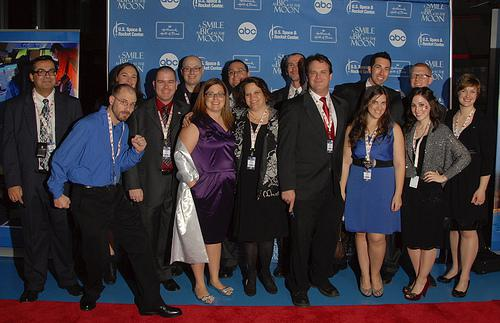Question: what network is being advertised?
Choices:
A. Nbc.
B. ABC.
C. Pbs.
D. Mtv.
Answer with the letter. Answer: B Question: what is hanging on their necks?
Choices:
A. Necklace.
B. Lanyards.
C. Glasses.
D. Towels.
Answer with the letter. Answer: B Question: why are they standing?
Choices:
A. To pose for a picture.
B. Exercise.
C. Stretch.
D. Walk.
Answer with the letter. Answer: A Question: what is on the arm of the woman in the purple blouse?
Choices:
A. A satin shawl.
B. Purse.
C. Towel.
D. Sweater.
Answer with the letter. Answer: A Question: who has dresses on?
Choices:
A. The women in front.
B. The bridesmaids.
C. The flowergirls.
D. The women in back.
Answer with the letter. Answer: A Question: who looks happy?
Choices:
A. Everyone.
B. The man.
C. The woman.
D. The child.
Answer with the letter. Answer: A 